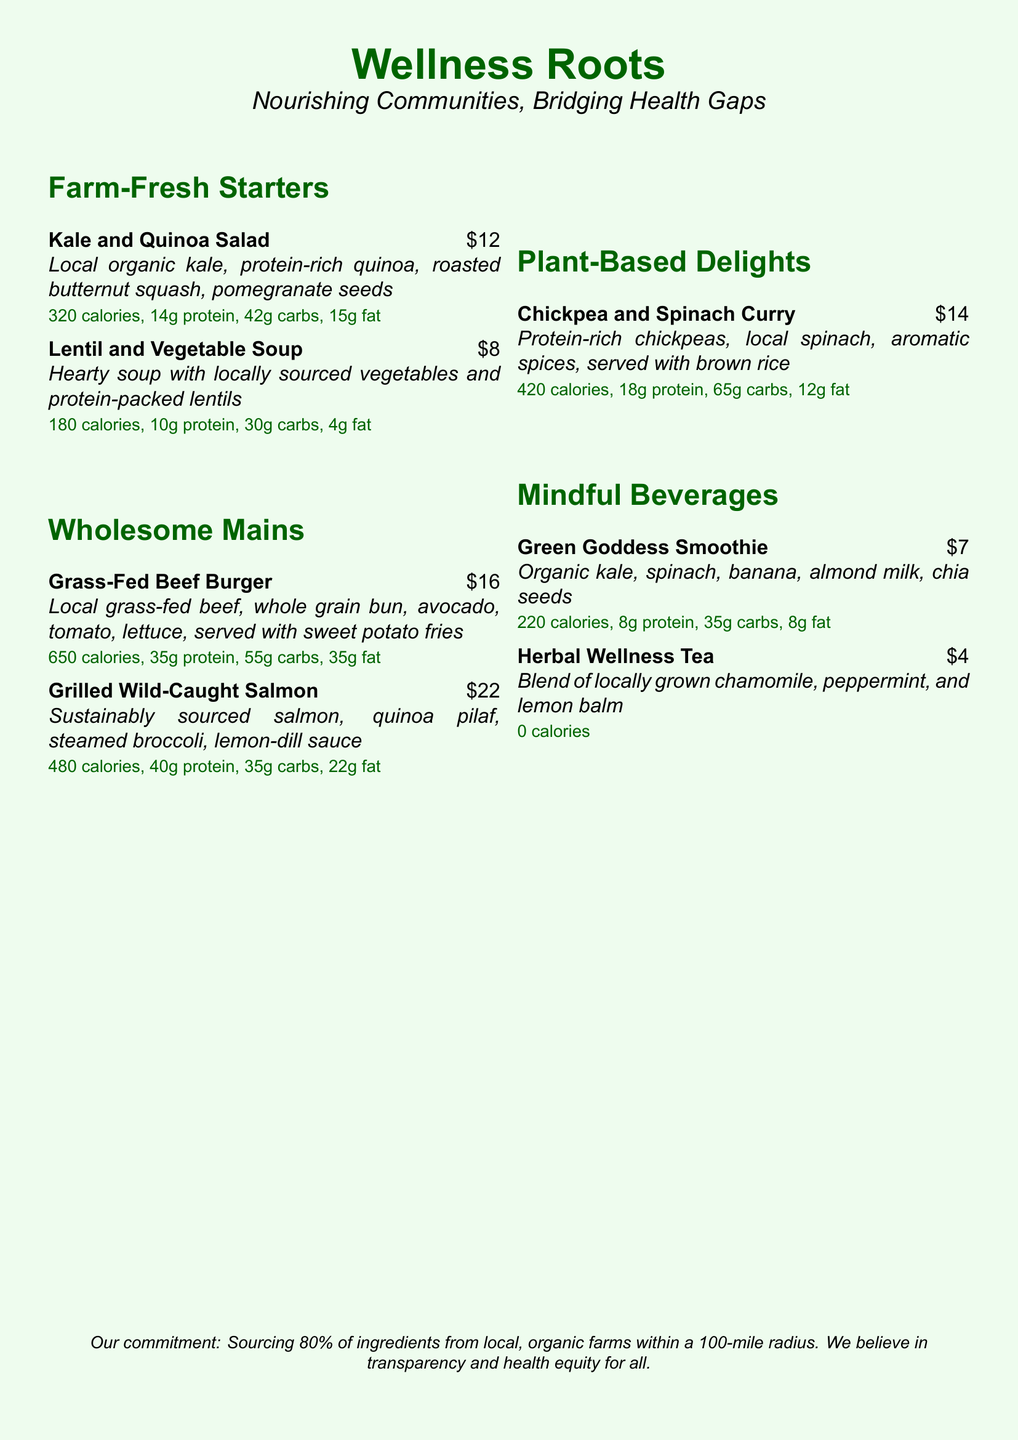What is the name of the restaurant? The name of the restaurant is the title at the top of the document.
Answer: Wellness Roots What are the calories in the Kale and Quinoa Salad? The calories for the Kale and Quinoa Salad are listed next to the dish description.
Answer: 320 calories What is the price of the Herbal Wellness Tea? The price is shown below the beverage description.
Answer: $4 How much protein is in the Grilled Wild-Caught Salmon? The protein amount is included with the nutritional information for the dish.
Answer: 40g protein Which item has the least amount of calories? This can be determined by comparing the calorie information of all menu items.
Answer: Herbal Wellness Tea What is the main ingredient in the Chickpea and Spinach Curry? The main ingredient is listed first in the dish description.
Answer: Chickpeas How many grams of carbs are in the Grass-Fed Beef Burger? The grams of carbs are part of the nutritional information for this dish.
Answer: 55g carbs Which section features plant-based options? The section titles will indicate where these options are found.
Answer: Plant-Based Delights What percentage of ingredients are sourced locally? The commitment statement indicates the percentage sourced locally.
Answer: 80% What is included in the Green Goddess Smoothie? The ingredients are listed in the description of the smoothie.
Answer: Organic kale, spinach, banana, almond milk, chia seeds 